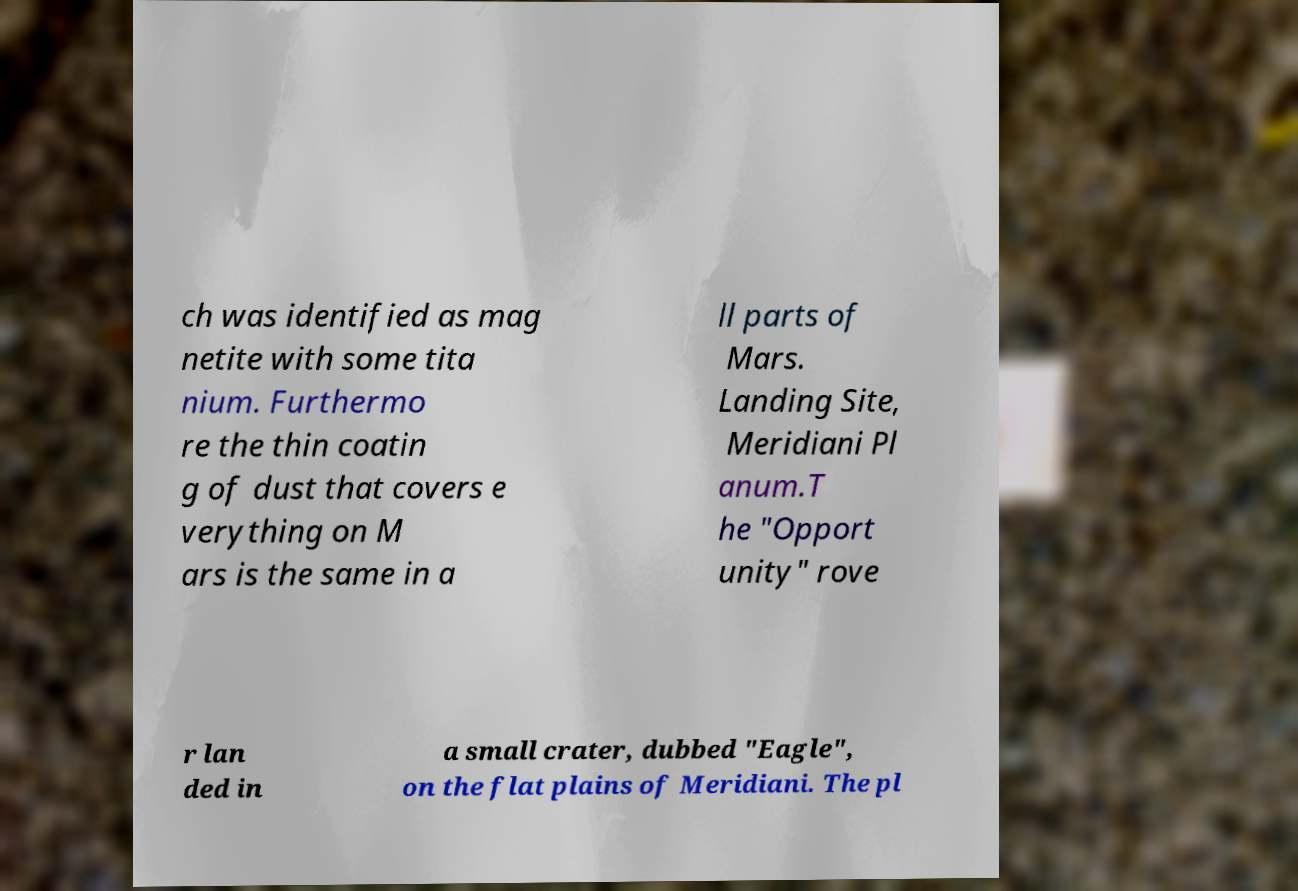Please identify and transcribe the text found in this image. ch was identified as mag netite with some tita nium. Furthermo re the thin coatin g of dust that covers e verything on M ars is the same in a ll parts of Mars. Landing Site, Meridiani Pl anum.T he "Opport unity" rove r lan ded in a small crater, dubbed "Eagle", on the flat plains of Meridiani. The pl 